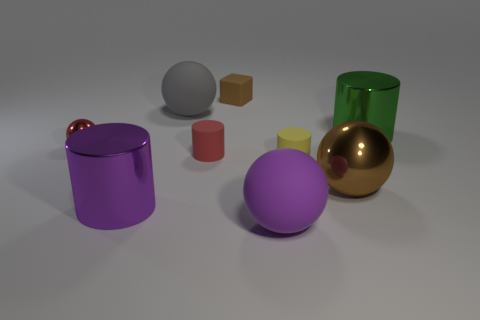There is a ball that is the same color as the matte cube; what is its size?
Ensure brevity in your answer.  Large. What is the shape of the small matte thing that is the same color as the small shiny sphere?
Provide a short and direct response. Cylinder. Is the number of large gray rubber objects that are behind the purple shiny thing greater than the number of purple shiny spheres?
Provide a succinct answer. Yes. Is there a gray object made of the same material as the tiny brown object?
Keep it short and to the point. Yes. There is a large rubber thing on the left side of the large purple matte ball; is its shape the same as the tiny red metal thing?
Give a very brief answer. Yes. What number of tiny yellow things are behind the metal ball on the right side of the large metal cylinder that is on the left side of the large gray sphere?
Your answer should be compact. 1. Are there fewer green cylinders that are on the right side of the small metal sphere than big objects that are behind the large shiny sphere?
Your answer should be very brief. Yes. What color is the other tiny object that is the same shape as the red matte object?
Your response must be concise. Yellow. What is the size of the green metal object?
Offer a terse response. Large. How many rubber objects are the same size as the green cylinder?
Keep it short and to the point. 2. 